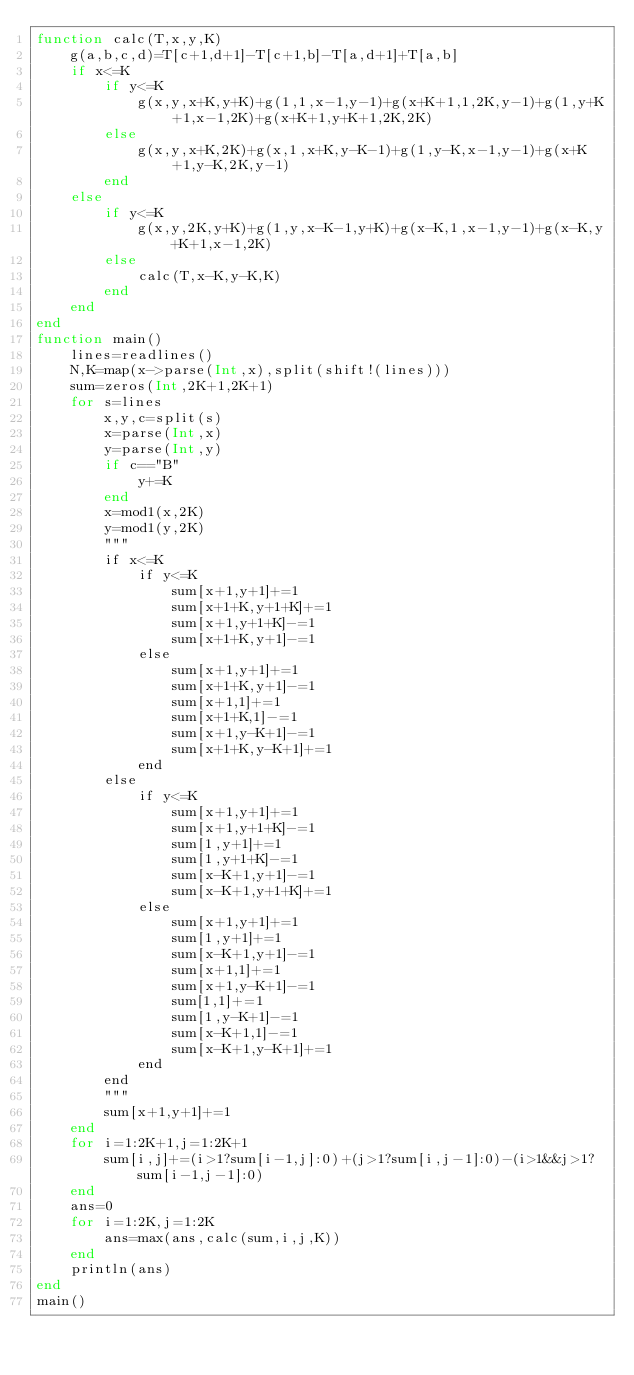Convert code to text. <code><loc_0><loc_0><loc_500><loc_500><_Julia_>function calc(T,x,y,K)
	g(a,b,c,d)=T[c+1,d+1]-T[c+1,b]-T[a,d+1]+T[a,b]
	if x<=K
		if y<=K
			g(x,y,x+K,y+K)+g(1,1,x-1,y-1)+g(x+K+1,1,2K,y-1)+g(1,y+K+1,x-1,2K)+g(x+K+1,y+K+1,2K,2K)
		else
			g(x,y,x+K,2K)+g(x,1,x+K,y-K-1)+g(1,y-K,x-1,y-1)+g(x+K+1,y-K,2K,y-1)
		end
	else
		if y<=K
			g(x,y,2K,y+K)+g(1,y,x-K-1,y+K)+g(x-K,1,x-1,y-1)+g(x-K,y+K+1,x-1,2K)
		else
			calc(T,x-K,y-K,K)
		end
	end
end
function main()
	lines=readlines()
	N,K=map(x->parse(Int,x),split(shift!(lines)))
	sum=zeros(Int,2K+1,2K+1)
	for s=lines
		x,y,c=split(s)
		x=parse(Int,x)
		y=parse(Int,y)
		if c=="B"
			y+=K
		end
		x=mod1(x,2K)
		y=mod1(y,2K)
		"""
		if x<=K
			if y<=K
				sum[x+1,y+1]+=1
				sum[x+1+K,y+1+K]+=1
				sum[x+1,y+1+K]-=1
				sum[x+1+K,y+1]-=1
			else
				sum[x+1,y+1]+=1
				sum[x+1+K,y+1]-=1
				sum[x+1,1]+=1
				sum[x+1+K,1]-=1
				sum[x+1,y-K+1]-=1
				sum[x+1+K,y-K+1]+=1
			end
		else
			if y<=K
				sum[x+1,y+1]+=1
				sum[x+1,y+1+K]-=1
				sum[1,y+1]+=1
				sum[1,y+1+K]-=1
				sum[x-K+1,y+1]-=1
				sum[x-K+1,y+1+K]+=1
			else
				sum[x+1,y+1]+=1
				sum[1,y+1]+=1
				sum[x-K+1,y+1]-=1
				sum[x+1,1]+=1
				sum[x+1,y-K+1]-=1
				sum[1,1]+=1
				sum[1,y-K+1]-=1
				sum[x-K+1,1]-=1
				sum[x-K+1,y-K+1]+=1
			end
		end
		"""
		sum[x+1,y+1]+=1
	end
	for i=1:2K+1,j=1:2K+1
		sum[i,j]+=(i>1?sum[i-1,j]:0)+(j>1?sum[i,j-1]:0)-(i>1&&j>1?sum[i-1,j-1]:0)
	end
	ans=0
	for i=1:2K,j=1:2K
		ans=max(ans,calc(sum,i,j,K))
	end
	println(ans)
end
main()
</code> 